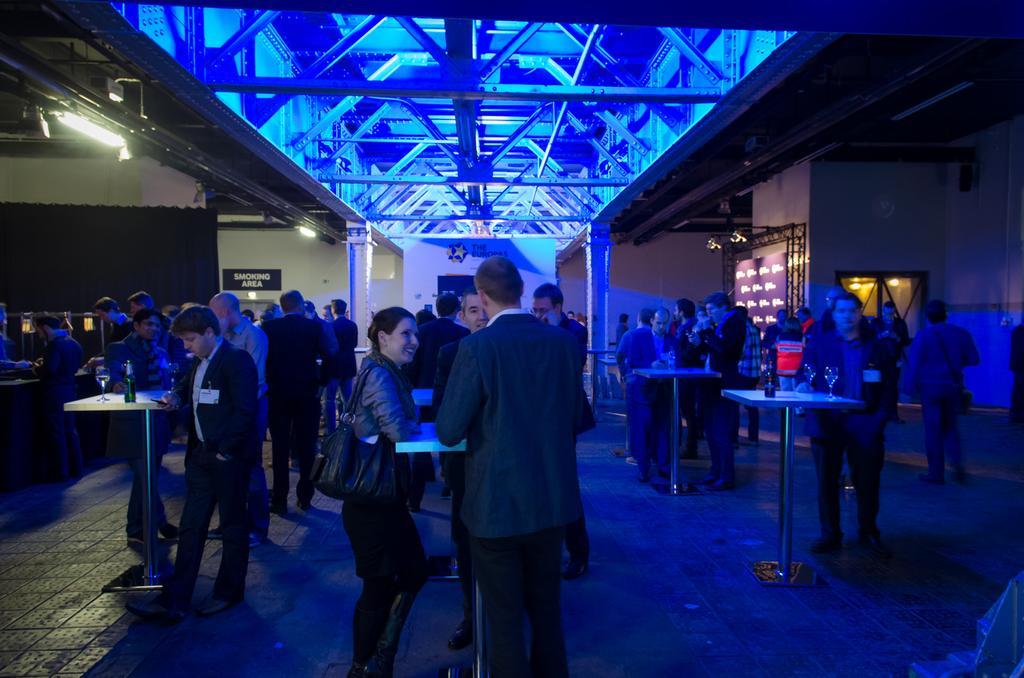In one or two sentences, can you explain what this image depicts? In the picture we can see a club inside the club we can see some tables and some wine bottles and glasses and some people are standing and having a drink and talking and in the background, we can see a wall with some curtain, smoking area board, and to the ceiling we can see some lights, rods. 